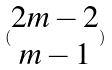<formula> <loc_0><loc_0><loc_500><loc_500>( \begin{matrix} 2 m - 2 \\ m - 1 \end{matrix} )</formula> 